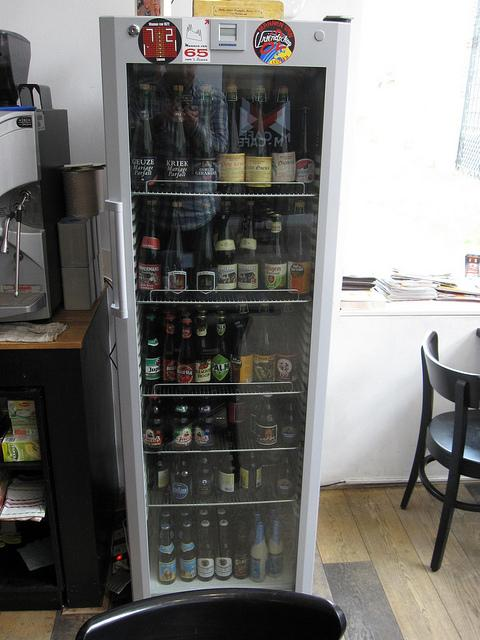What drink has the owner of this cooler stocked up on? beer 